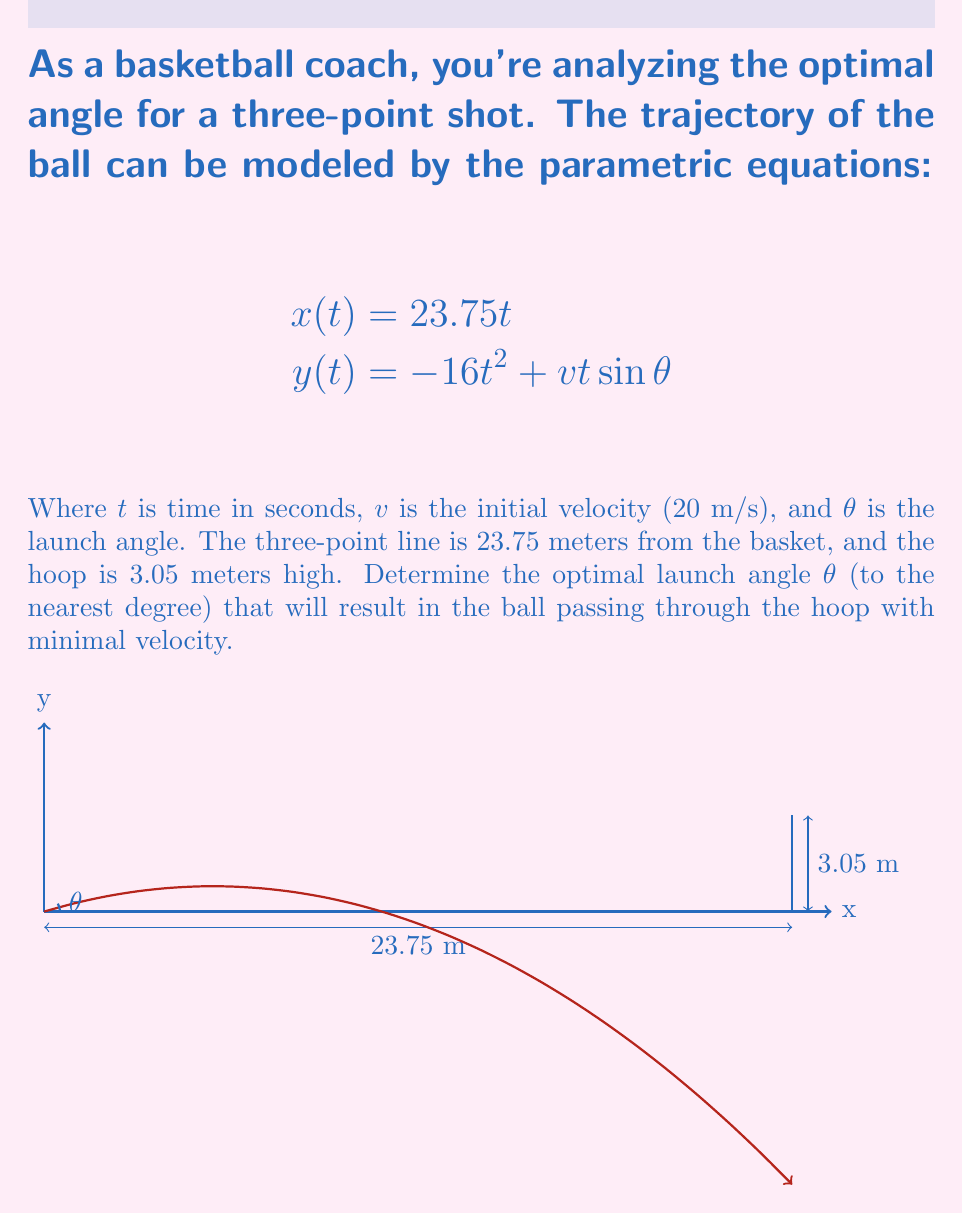Provide a solution to this math problem. Let's approach this step-by-step:

1) We know that the ball must reach the hoop at x = 23.75 m and y = 3.05 m. We can use these conditions in our parametric equations.

2) From the x-equation, we can find the time it takes to reach the hoop:
   $$23.75 = 23.75t$$
   $$t = 1 \text{ second}$$

3) Now, we can use this time in the y-equation:
   $$3.05 = -16(1)^2 + 20\sin\theta(1)$$
   $$3.05 = -16 + 20\sin\theta$$
   $$19.05 = 20\sin\theta$$
   $$\sin\theta = \frac{19.05}{20} = 0.9525$$

4) To find $\theta$, we take the inverse sine:
   $$\theta = \arcsin(0.9525) \approx 72.38^\circ$$

5) To minimize velocity, we want the ball to just barely clear the hoop. This angle gives us that trajectory.

6) Rounding to the nearest degree, we get 72°.
Answer: 72° 